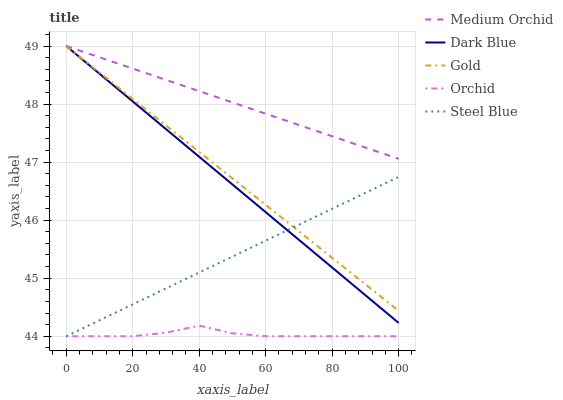Does Orchid have the minimum area under the curve?
Answer yes or no. Yes. Does Medium Orchid have the maximum area under the curve?
Answer yes or no. Yes. Does Steel Blue have the minimum area under the curve?
Answer yes or no. No. Does Steel Blue have the maximum area under the curve?
Answer yes or no. No. Is Medium Orchid the smoothest?
Answer yes or no. Yes. Is Orchid the roughest?
Answer yes or no. Yes. Is Steel Blue the smoothest?
Answer yes or no. No. Is Steel Blue the roughest?
Answer yes or no. No. Does Steel Blue have the lowest value?
Answer yes or no. Yes. Does Medium Orchid have the lowest value?
Answer yes or no. No. Does Gold have the highest value?
Answer yes or no. Yes. Does Steel Blue have the highest value?
Answer yes or no. No. Is Orchid less than Gold?
Answer yes or no. Yes. Is Gold greater than Orchid?
Answer yes or no. Yes. Does Steel Blue intersect Orchid?
Answer yes or no. Yes. Is Steel Blue less than Orchid?
Answer yes or no. No. Is Steel Blue greater than Orchid?
Answer yes or no. No. Does Orchid intersect Gold?
Answer yes or no. No. 